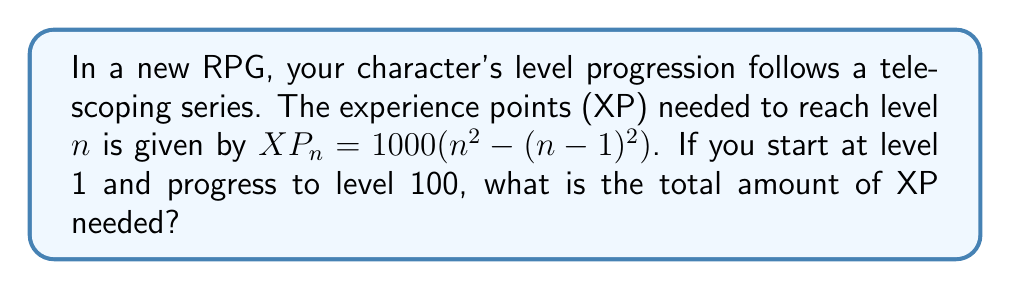Show me your answer to this math problem. Let's approach this step-by-step:

1) First, we need to understand the telescoping series. The XP needed for each level is:

   $XP_n = 1000(n^2 - (n-1)^2)$

2) We want to find the sum of this series from n = 1 to 100. Let's call this sum S:

   $S = \sum_{n=1}^{100} 1000(n^2 - (n-1)^2)$

3) Let's expand the squared term:

   $S = 1000 \sum_{n=1}^{100} (n^2 - (n^2 - 2n + 1))$

4) Simplify:

   $S = 1000 \sum_{n=1}^{100} (2n - 1)$

5) Now, we can factor out the 1000:

   $S = 1000 (2 \sum_{n=1}^{100} n - \sum_{n=1}^{100} 1)$

6) We know the sum of the first 100 integers:

   $\sum_{n=1}^{100} n = \frac{100(100+1)}{2} = 5050$

7) And the sum of 1, 100 times is just 100.

8) Substituting these in:

   $S = 1000 (2(5050) - 100)$

9) Simplify:

   $S = 1000 (10100 - 100) = 1000 (10000) = 10,000,000$

Therefore, the total XP needed to progress from level 1 to level 100 is 10,000,000.
Answer: 10,000,000 XP 